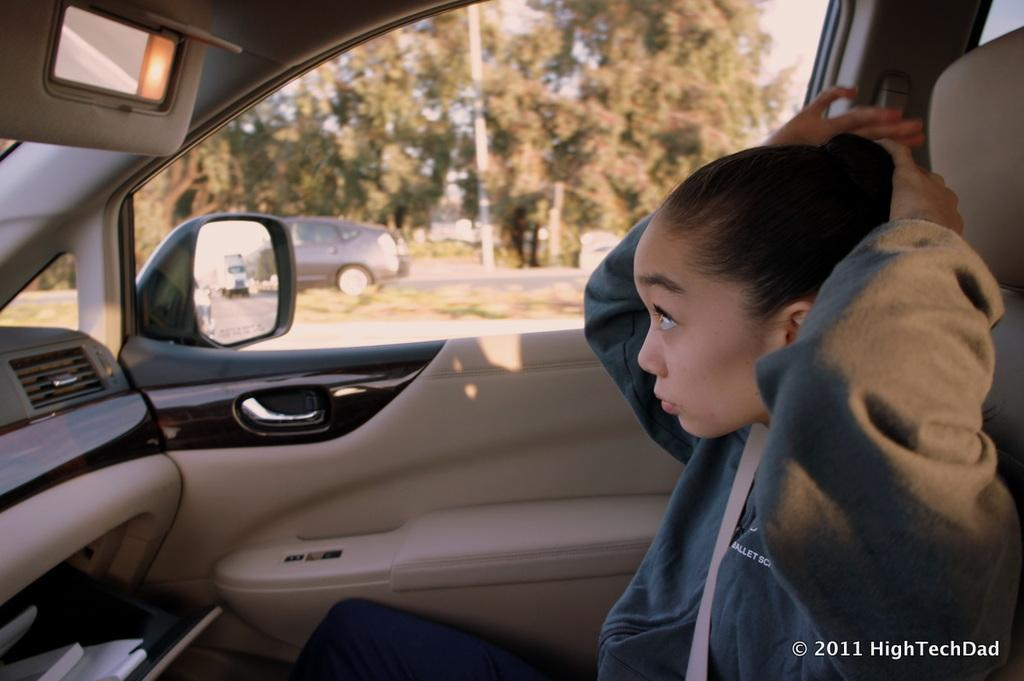What is the woman doing in the image? The woman is sitting on a car in the image. What can be seen in the background of the image? There are trees visible in the background of the image. What else is present in the image besides the woman and the car? There is another vehicle on the right side of the image. What type of stone is being used to form the car in the image? There is no indication in the image that the car is made of stone, and it is not possible to determine the material used to form the car from the image alone. 